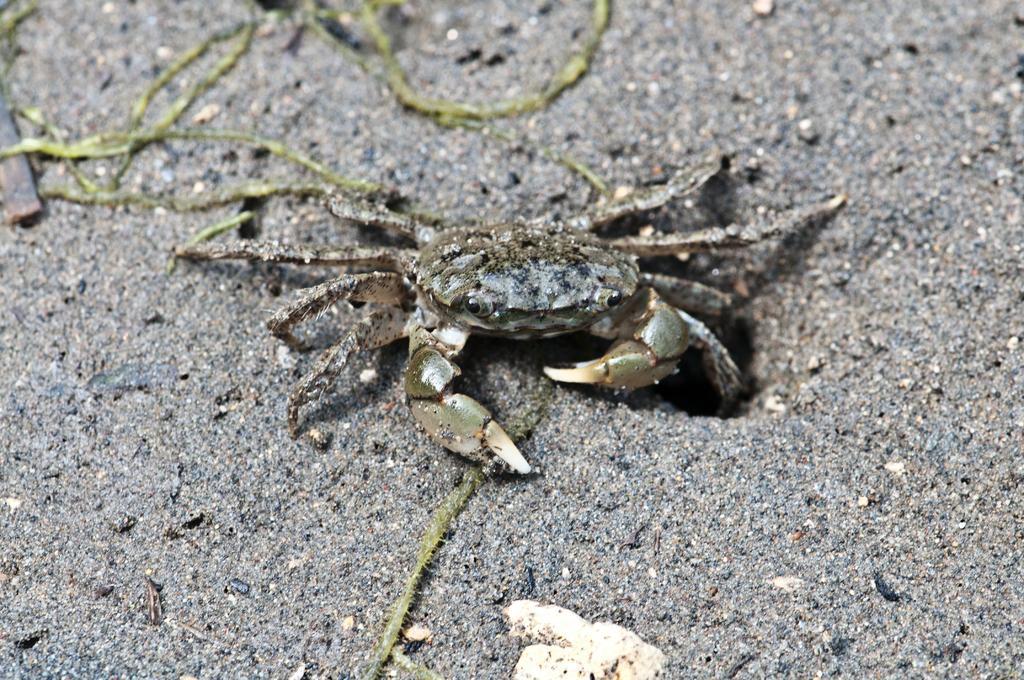Can you describe this image briefly? In the center of the image there is a freshwater crab present on the ground. 